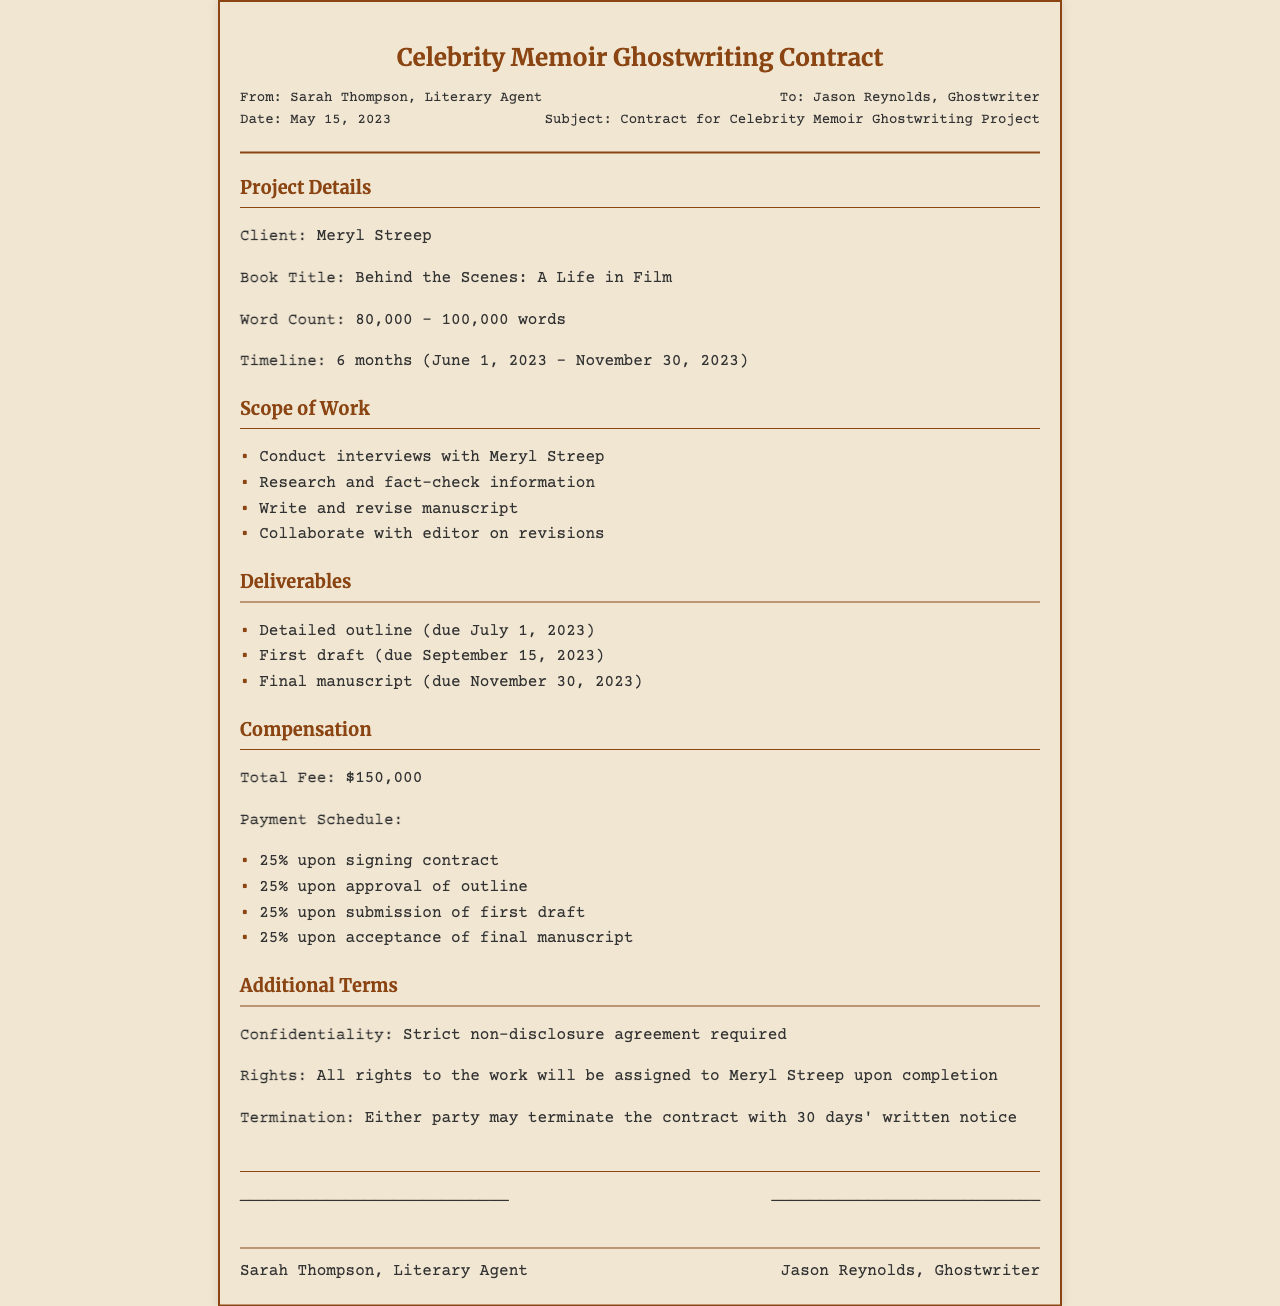What is the client's name? The client's name is stated in the project details section of the document.
Answer: Meryl Streep What is the total fee for the project? The total fee for the ghostwriting project is mentioned under the compensation section.
Answer: $150,000 What is the due date for the first draft? The due date for the first draft is specified in the deliverables section.
Answer: September 15, 2023 How long is the project timeline? The project timeline can be calculated based on the start and end dates mentioned in the project details.
Answer: 6 months What percentage is paid upon signing the contract? The payment schedule specifies the percentage paid upon signing the contract.
Answer: 25% What is the start date of the project? The start date of the project is indicated in the timeline provided.
Answer: June 1, 2023 What key task involves Meryl Streep? The scope of work details the tasks that will involve Meryl Streep during the project.
Answer: Conduct interviews What rights are assigned upon completion? The rights associated with the work upon completion are mentioned in the additional terms section.
Answer: All rights How many deliverables are specified in the contract? The deliverables section outlines the number of distinct deliverables required for the project.
Answer: 3 